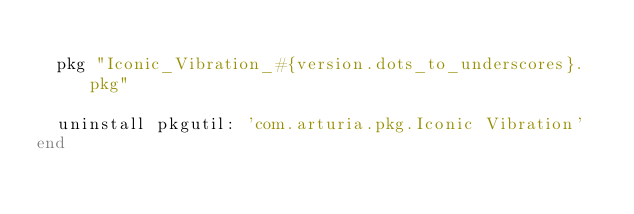<code> <loc_0><loc_0><loc_500><loc_500><_Ruby_>
  pkg "Iconic_Vibration_#{version.dots_to_underscores}.pkg"

  uninstall pkgutil: 'com.arturia.pkg.Iconic Vibration'
end
</code> 